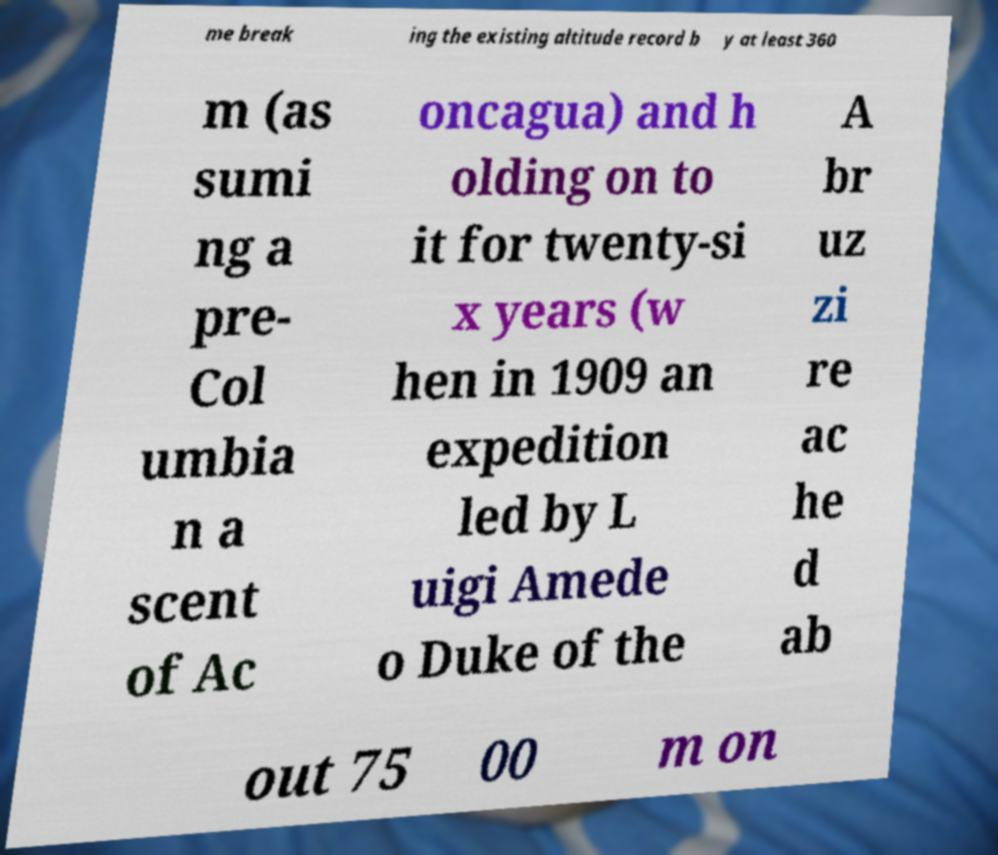Can you read and provide the text displayed in the image?This photo seems to have some interesting text. Can you extract and type it out for me? me break ing the existing altitude record b y at least 360 m (as sumi ng a pre- Col umbia n a scent of Ac oncagua) and h olding on to it for twenty-si x years (w hen in 1909 an expedition led by L uigi Amede o Duke of the A br uz zi re ac he d ab out 75 00 m on 